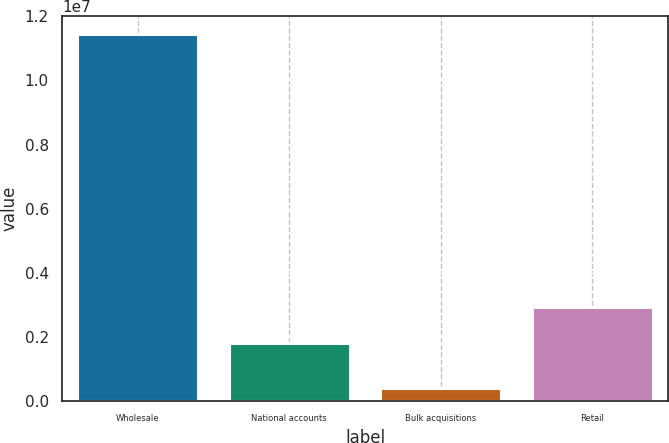Convert chart to OTSL. <chart><loc_0><loc_0><loc_500><loc_500><bar_chart><fcel>Wholesale<fcel>National accounts<fcel>Bulk acquisitions<fcel>Retail<nl><fcel>1.14341e+07<fcel>1.81409e+06<fcel>411013<fcel>2.91838e+06<nl></chart> 